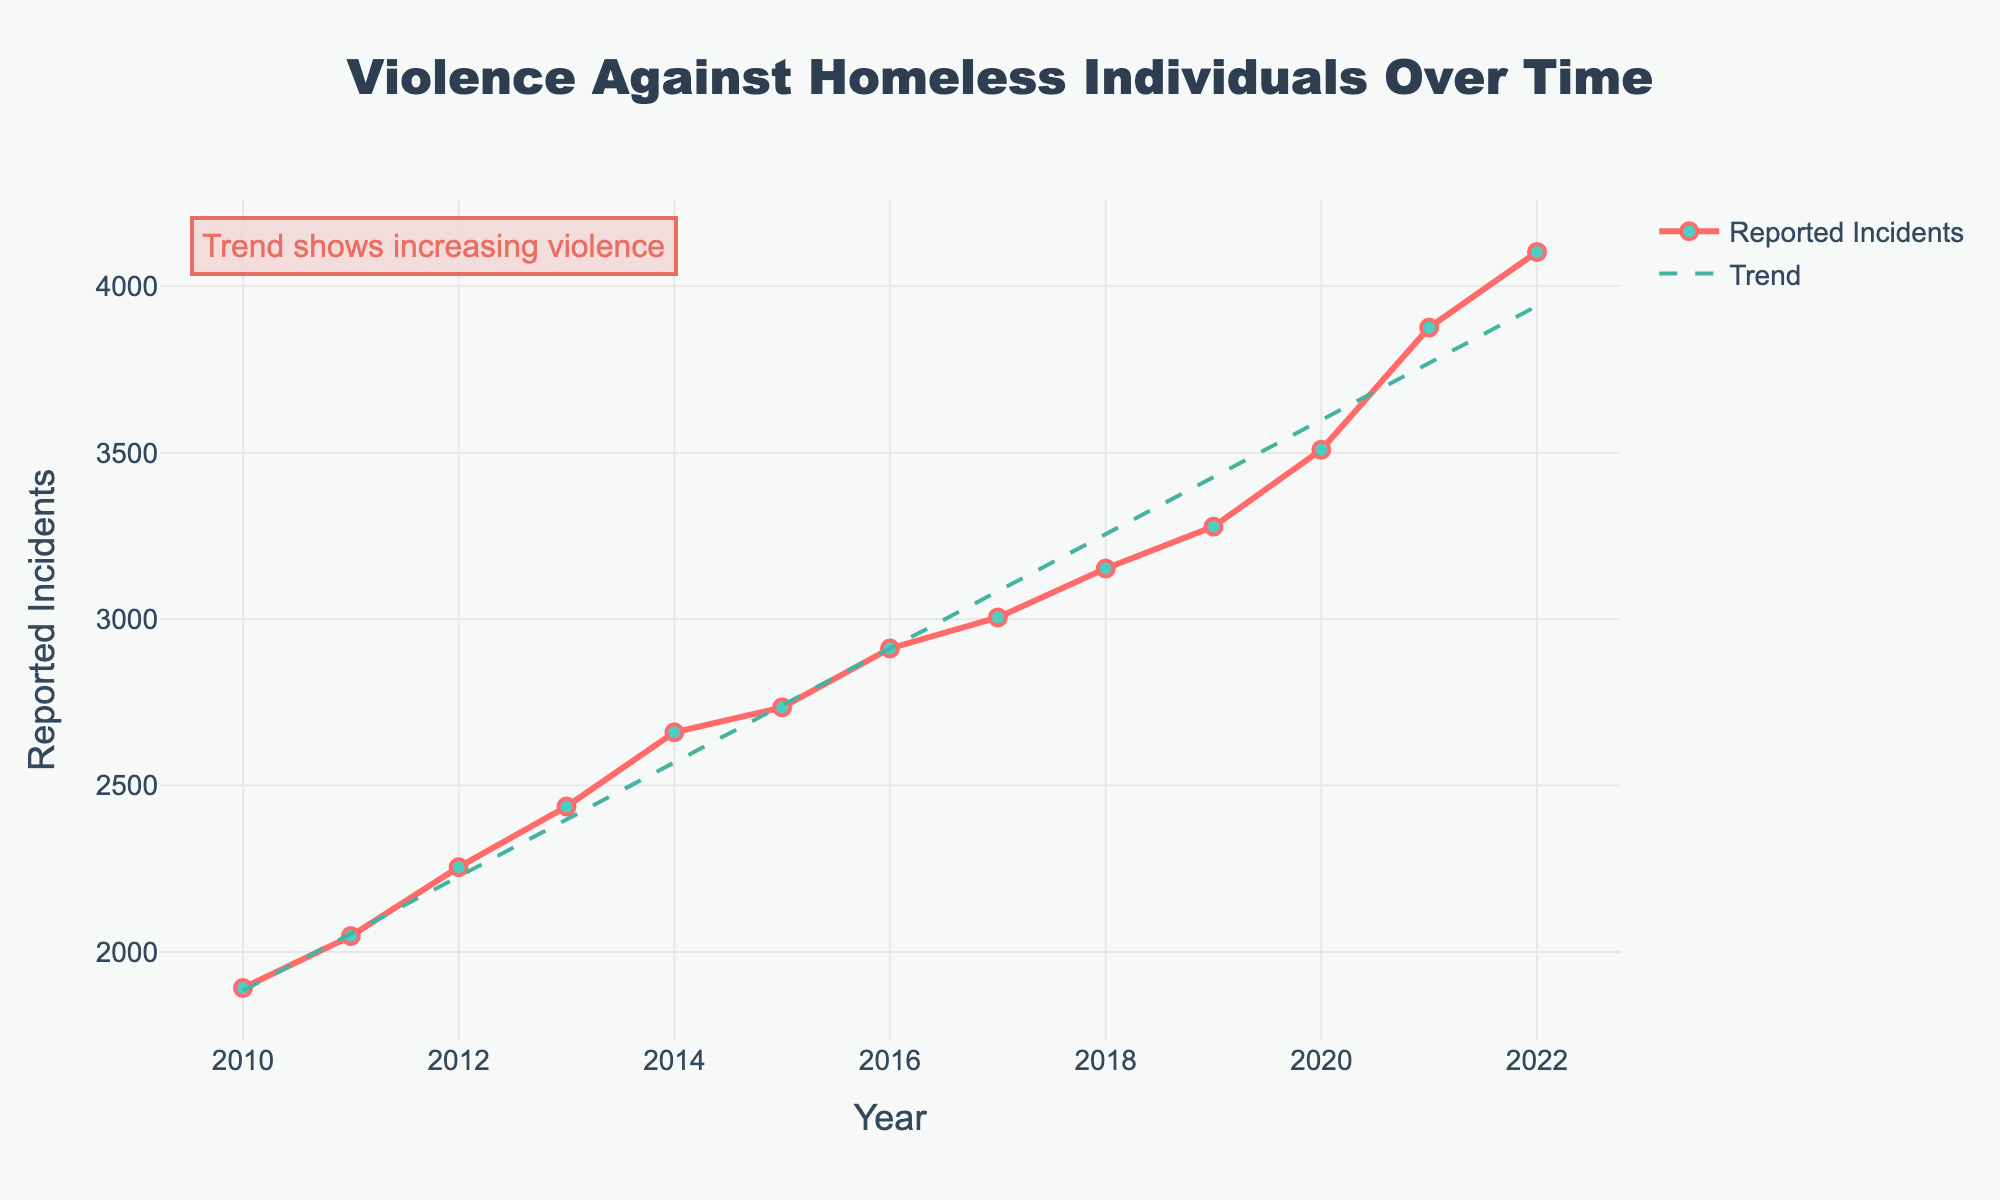Which year had the highest reported incidents of violence against homeless individuals? To determine the year with the highest reported incidents, look for the peak value along the y-axis and check its corresponding position on the x-axis. The highest point is at 2022 with 4103 incidents
Answer: 2022 How much did reported incidents increase from 2010 to 2022? To find the increase, subtract the number of incidents in 2010 from the number in 2022. From the chart, 2022 has 4103 incidents and 2010 has 1892 incidents. The increase is 4103 - 1892 = 2211
Answer: 2211 By what amount did the reported incidents grow annually on average between 2010 and 2022? First, calculate the total increase from 2010 to 2022, which is 2211 incidents. Then, divide by the number of years, which is 2022-2010 = 12 years. The average annual increase is 2211 / 12 = 184.25
Answer: 184.25 In which year did the reported incidents cross the 3000 mark for the first time? Look for the point where the line first crosses the 3000 mark on the y-axis and check its corresponding year on the x-axis. The line first crosses 3000 in the year 2017
Answer: 2017 Between which two consecutive years was the largest increase in reported incidents observed? Identify the points on the line with the steepest positive slope. Calculate the differences between consecutive years and find the maximum difference. The largest increase is between 2020 (3509) and 2021 (3876), with an increase of 3876 - 3509 = 367
Answer: 2020 and 2021 How does the trend line visually compare to the data points from 2010 to 2022? The trend line generally follows the increasing pattern of the data points, suggesting a consistent upward trajectory in reported incidents of violence over these years
Answer: Consistent upward trajectory Is there any year where the reported incidents decreased compared to the previous year? Examine each pair of consecutive points to see if any line segment slopes downward. The line trends upward throughout the figure, indicating no decrease
Answer: No What is the most noticeable annotation highlighted in the chart? Look for any text directly on the chart. The annotation "Trend shows increasing violence" is noticeable in the upper-left corner of the chart
Answer: Trend shows increasing violence What is the approximate trend value for the year 2015? Find the trend line's value at 2015 by following the trend line and aligning it with the 2015 mark on the x-axis. The trend line at 2015 approximates to around 2735
Answer: 2735 